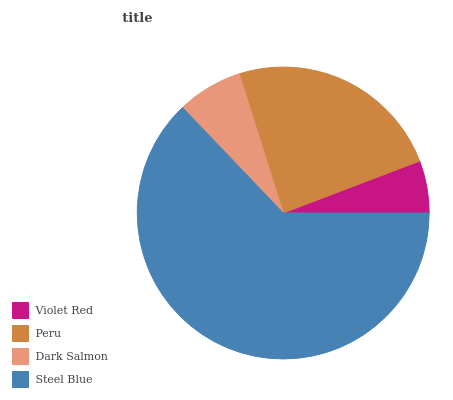Is Violet Red the minimum?
Answer yes or no. Yes. Is Steel Blue the maximum?
Answer yes or no. Yes. Is Peru the minimum?
Answer yes or no. No. Is Peru the maximum?
Answer yes or no. No. Is Peru greater than Violet Red?
Answer yes or no. Yes. Is Violet Red less than Peru?
Answer yes or no. Yes. Is Violet Red greater than Peru?
Answer yes or no. No. Is Peru less than Violet Red?
Answer yes or no. No. Is Peru the high median?
Answer yes or no. Yes. Is Dark Salmon the low median?
Answer yes or no. Yes. Is Violet Red the high median?
Answer yes or no. No. Is Peru the low median?
Answer yes or no. No. 